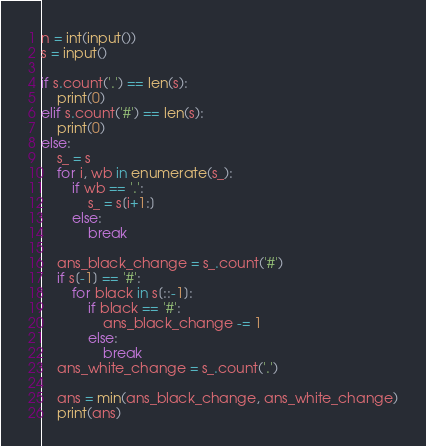<code> <loc_0><loc_0><loc_500><loc_500><_Python_>n = int(input())
s = input()
 
if s.count('.') == len(s):
    print(0)
elif s.count('#') == len(s):
    print(0)
else:
    s_ = s
    for i, wb in enumerate(s_):
        if wb == '.':
            s_ = s[i+1:]
        else:
            break
    
    ans_black_change = s_.count('#')
    if s[-1] == '#':
        for black in s[::-1]:
            if black == '#':
                ans_black_change -= 1
            else:
                break
    ans_white_change = s_.count('.')
    
    ans = min(ans_black_change, ans_white_change)
    print(ans)</code> 